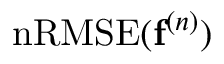Convert formula to latex. <formula><loc_0><loc_0><loc_500><loc_500>n R M S E ( f ^ { ( n ) } )</formula> 